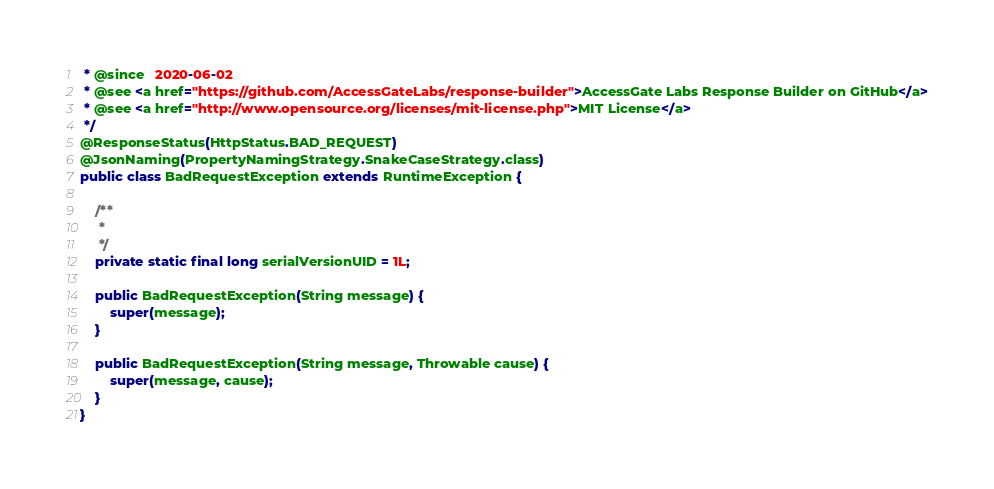<code> <loc_0><loc_0><loc_500><loc_500><_Java_> * @since   2020-06-02
 * @see <a href="https://github.com/AccessGateLabs/response-builder">AccessGate Labs Response Builder on GitHub</a>
 * @see <a href="http://www.opensource.org/licenses/mit-license.php">MIT License</a>
 */
@ResponseStatus(HttpStatus.BAD_REQUEST)
@JsonNaming(PropertyNamingStrategy.SnakeCaseStrategy.class)
public class BadRequestException extends RuntimeException {

    /**
	 * 
	 */
	private static final long serialVersionUID = 1L;

	public BadRequestException(String message) {
        super(message);
    }

    public BadRequestException(String message, Throwable cause) {
        super(message, cause);
    }
}
</code> 